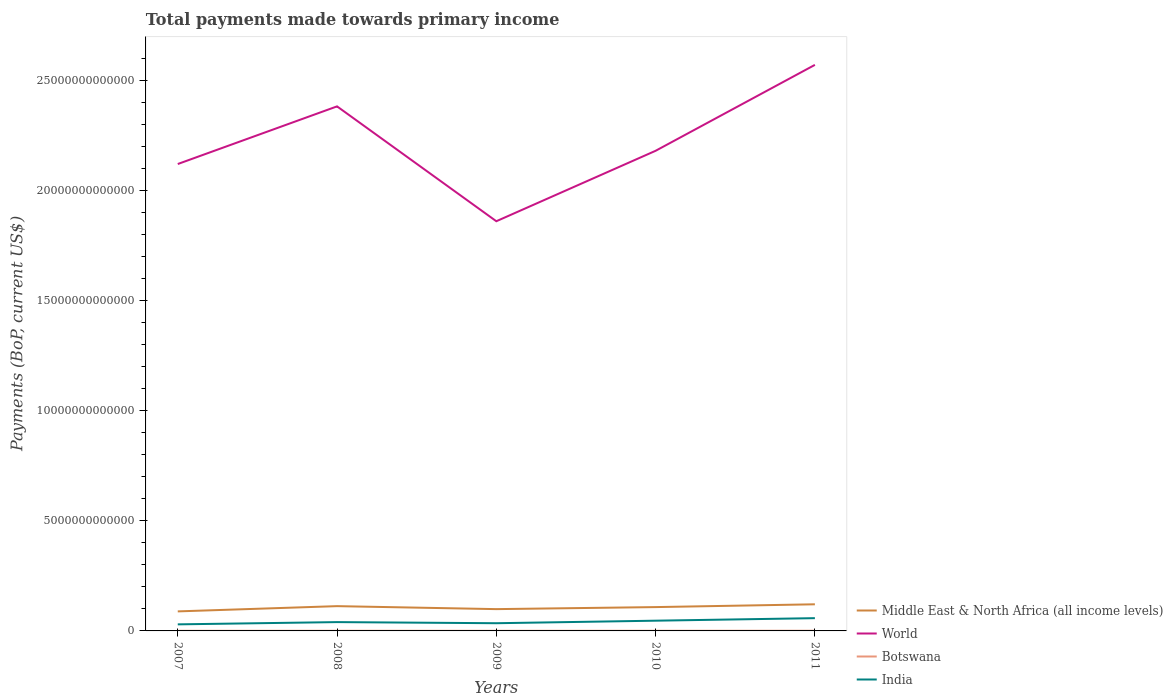How many different coloured lines are there?
Ensure brevity in your answer.  4. Does the line corresponding to World intersect with the line corresponding to Middle East & North Africa (all income levels)?
Ensure brevity in your answer.  No. Across all years, what is the maximum total payments made towards primary income in Botswana?
Keep it short and to the point. 5.86e+09. In which year was the total payments made towards primary income in Botswana maximum?
Provide a short and direct response. 2009. What is the total total payments made towards primary income in World in the graph?
Ensure brevity in your answer.  -2.62e+12. What is the difference between the highest and the second highest total payments made towards primary income in World?
Ensure brevity in your answer.  7.10e+12. How many years are there in the graph?
Offer a very short reply. 5. What is the difference between two consecutive major ticks on the Y-axis?
Offer a very short reply. 5.00e+12. Are the values on the major ticks of Y-axis written in scientific E-notation?
Ensure brevity in your answer.  No. Does the graph contain any zero values?
Your response must be concise. No. What is the title of the graph?
Provide a succinct answer. Total payments made towards primary income. What is the label or title of the Y-axis?
Ensure brevity in your answer.  Payments (BoP, current US$). What is the Payments (BoP, current US$) of Middle East & North Africa (all income levels) in 2007?
Your answer should be very brief. 8.86e+11. What is the Payments (BoP, current US$) in World in 2007?
Your answer should be very brief. 2.12e+13. What is the Payments (BoP, current US$) of Botswana in 2007?
Offer a very short reply. 6.00e+09. What is the Payments (BoP, current US$) in India in 2007?
Give a very brief answer. 2.98e+11. What is the Payments (BoP, current US$) in Middle East & North Africa (all income levels) in 2008?
Ensure brevity in your answer.  1.12e+12. What is the Payments (BoP, current US$) in World in 2008?
Make the answer very short. 2.38e+13. What is the Payments (BoP, current US$) in Botswana in 2008?
Your response must be concise. 6.81e+09. What is the Payments (BoP, current US$) of India in 2008?
Your response must be concise. 4.00e+11. What is the Payments (BoP, current US$) in Middle East & North Africa (all income levels) in 2009?
Offer a terse response. 9.90e+11. What is the Payments (BoP, current US$) of World in 2009?
Give a very brief answer. 1.86e+13. What is the Payments (BoP, current US$) in Botswana in 2009?
Make the answer very short. 5.86e+09. What is the Payments (BoP, current US$) in India in 2009?
Make the answer very short. 3.50e+11. What is the Payments (BoP, current US$) in Middle East & North Africa (all income levels) in 2010?
Offer a very short reply. 1.08e+12. What is the Payments (BoP, current US$) of World in 2010?
Keep it short and to the point. 2.18e+13. What is the Payments (BoP, current US$) in Botswana in 2010?
Ensure brevity in your answer.  7.16e+09. What is the Payments (BoP, current US$) in India in 2010?
Your response must be concise. 4.65e+11. What is the Payments (BoP, current US$) in Middle East & North Africa (all income levels) in 2011?
Make the answer very short. 1.21e+12. What is the Payments (BoP, current US$) of World in 2011?
Your response must be concise. 2.57e+13. What is the Payments (BoP, current US$) in Botswana in 2011?
Your answer should be compact. 8.39e+09. What is the Payments (BoP, current US$) in India in 2011?
Your answer should be very brief. 5.79e+11. Across all years, what is the maximum Payments (BoP, current US$) in Middle East & North Africa (all income levels)?
Keep it short and to the point. 1.21e+12. Across all years, what is the maximum Payments (BoP, current US$) in World?
Provide a short and direct response. 2.57e+13. Across all years, what is the maximum Payments (BoP, current US$) in Botswana?
Provide a short and direct response. 8.39e+09. Across all years, what is the maximum Payments (BoP, current US$) in India?
Ensure brevity in your answer.  5.79e+11. Across all years, what is the minimum Payments (BoP, current US$) in Middle East & North Africa (all income levels)?
Make the answer very short. 8.86e+11. Across all years, what is the minimum Payments (BoP, current US$) of World?
Your answer should be very brief. 1.86e+13. Across all years, what is the minimum Payments (BoP, current US$) in Botswana?
Offer a terse response. 5.86e+09. Across all years, what is the minimum Payments (BoP, current US$) in India?
Make the answer very short. 2.98e+11. What is the total Payments (BoP, current US$) in Middle East & North Africa (all income levels) in the graph?
Offer a very short reply. 5.29e+12. What is the total Payments (BoP, current US$) of World in the graph?
Make the answer very short. 1.11e+14. What is the total Payments (BoP, current US$) in Botswana in the graph?
Your response must be concise. 3.42e+1. What is the total Payments (BoP, current US$) in India in the graph?
Provide a succinct answer. 2.09e+12. What is the difference between the Payments (BoP, current US$) in Middle East & North Africa (all income levels) in 2007 and that in 2008?
Your answer should be compact. -2.38e+11. What is the difference between the Payments (BoP, current US$) in World in 2007 and that in 2008?
Give a very brief answer. -2.62e+12. What is the difference between the Payments (BoP, current US$) in Botswana in 2007 and that in 2008?
Your answer should be compact. -8.14e+08. What is the difference between the Payments (BoP, current US$) of India in 2007 and that in 2008?
Your response must be concise. -1.02e+11. What is the difference between the Payments (BoP, current US$) of Middle East & North Africa (all income levels) in 2007 and that in 2009?
Your answer should be very brief. -1.03e+11. What is the difference between the Payments (BoP, current US$) in World in 2007 and that in 2009?
Your response must be concise. 2.60e+12. What is the difference between the Payments (BoP, current US$) in Botswana in 2007 and that in 2009?
Provide a short and direct response. 1.35e+08. What is the difference between the Payments (BoP, current US$) in India in 2007 and that in 2009?
Provide a succinct answer. -5.16e+1. What is the difference between the Payments (BoP, current US$) in Middle East & North Africa (all income levels) in 2007 and that in 2010?
Offer a very short reply. -1.96e+11. What is the difference between the Payments (BoP, current US$) of World in 2007 and that in 2010?
Provide a short and direct response. -6.01e+11. What is the difference between the Payments (BoP, current US$) in Botswana in 2007 and that in 2010?
Make the answer very short. -1.17e+09. What is the difference between the Payments (BoP, current US$) in India in 2007 and that in 2010?
Your answer should be compact. -1.67e+11. What is the difference between the Payments (BoP, current US$) of Middle East & North Africa (all income levels) in 2007 and that in 2011?
Ensure brevity in your answer.  -3.22e+11. What is the difference between the Payments (BoP, current US$) in World in 2007 and that in 2011?
Keep it short and to the point. -4.50e+12. What is the difference between the Payments (BoP, current US$) of Botswana in 2007 and that in 2011?
Your answer should be compact. -2.40e+09. What is the difference between the Payments (BoP, current US$) of India in 2007 and that in 2011?
Provide a short and direct response. -2.81e+11. What is the difference between the Payments (BoP, current US$) of Middle East & North Africa (all income levels) in 2008 and that in 2009?
Keep it short and to the point. 1.35e+11. What is the difference between the Payments (BoP, current US$) of World in 2008 and that in 2009?
Offer a terse response. 5.21e+12. What is the difference between the Payments (BoP, current US$) of Botswana in 2008 and that in 2009?
Offer a terse response. 9.49e+08. What is the difference between the Payments (BoP, current US$) in India in 2008 and that in 2009?
Offer a very short reply. 5.09e+1. What is the difference between the Payments (BoP, current US$) of Middle East & North Africa (all income levels) in 2008 and that in 2010?
Provide a short and direct response. 4.28e+1. What is the difference between the Payments (BoP, current US$) in World in 2008 and that in 2010?
Your answer should be very brief. 2.02e+12. What is the difference between the Payments (BoP, current US$) in Botswana in 2008 and that in 2010?
Give a very brief answer. -3.52e+08. What is the difference between the Payments (BoP, current US$) in India in 2008 and that in 2010?
Offer a very short reply. -6.42e+1. What is the difference between the Payments (BoP, current US$) of Middle East & North Africa (all income levels) in 2008 and that in 2011?
Your answer should be compact. -8.36e+1. What is the difference between the Payments (BoP, current US$) of World in 2008 and that in 2011?
Keep it short and to the point. -1.88e+12. What is the difference between the Payments (BoP, current US$) in Botswana in 2008 and that in 2011?
Offer a very short reply. -1.58e+09. What is the difference between the Payments (BoP, current US$) of India in 2008 and that in 2011?
Offer a very short reply. -1.79e+11. What is the difference between the Payments (BoP, current US$) of Middle East & North Africa (all income levels) in 2009 and that in 2010?
Your answer should be compact. -9.24e+1. What is the difference between the Payments (BoP, current US$) of World in 2009 and that in 2010?
Keep it short and to the point. -3.20e+12. What is the difference between the Payments (BoP, current US$) in Botswana in 2009 and that in 2010?
Keep it short and to the point. -1.30e+09. What is the difference between the Payments (BoP, current US$) of India in 2009 and that in 2010?
Provide a succinct answer. -1.15e+11. What is the difference between the Payments (BoP, current US$) in Middle East & North Africa (all income levels) in 2009 and that in 2011?
Ensure brevity in your answer.  -2.19e+11. What is the difference between the Payments (BoP, current US$) in World in 2009 and that in 2011?
Offer a very short reply. -7.10e+12. What is the difference between the Payments (BoP, current US$) in Botswana in 2009 and that in 2011?
Offer a terse response. -2.53e+09. What is the difference between the Payments (BoP, current US$) in India in 2009 and that in 2011?
Offer a terse response. -2.30e+11. What is the difference between the Payments (BoP, current US$) of Middle East & North Africa (all income levels) in 2010 and that in 2011?
Offer a very short reply. -1.26e+11. What is the difference between the Payments (BoP, current US$) of World in 2010 and that in 2011?
Ensure brevity in your answer.  -3.90e+12. What is the difference between the Payments (BoP, current US$) of Botswana in 2010 and that in 2011?
Your response must be concise. -1.23e+09. What is the difference between the Payments (BoP, current US$) of India in 2010 and that in 2011?
Offer a terse response. -1.15e+11. What is the difference between the Payments (BoP, current US$) in Middle East & North Africa (all income levels) in 2007 and the Payments (BoP, current US$) in World in 2008?
Make the answer very short. -2.29e+13. What is the difference between the Payments (BoP, current US$) in Middle East & North Africa (all income levels) in 2007 and the Payments (BoP, current US$) in Botswana in 2008?
Offer a terse response. 8.80e+11. What is the difference between the Payments (BoP, current US$) in Middle East & North Africa (all income levels) in 2007 and the Payments (BoP, current US$) in India in 2008?
Give a very brief answer. 4.86e+11. What is the difference between the Payments (BoP, current US$) of World in 2007 and the Payments (BoP, current US$) of Botswana in 2008?
Provide a short and direct response. 2.12e+13. What is the difference between the Payments (BoP, current US$) in World in 2007 and the Payments (BoP, current US$) in India in 2008?
Provide a short and direct response. 2.08e+13. What is the difference between the Payments (BoP, current US$) in Botswana in 2007 and the Payments (BoP, current US$) in India in 2008?
Offer a terse response. -3.94e+11. What is the difference between the Payments (BoP, current US$) of Middle East & North Africa (all income levels) in 2007 and the Payments (BoP, current US$) of World in 2009?
Provide a short and direct response. -1.77e+13. What is the difference between the Payments (BoP, current US$) in Middle East & North Africa (all income levels) in 2007 and the Payments (BoP, current US$) in Botswana in 2009?
Provide a succinct answer. 8.81e+11. What is the difference between the Payments (BoP, current US$) in Middle East & North Africa (all income levels) in 2007 and the Payments (BoP, current US$) in India in 2009?
Give a very brief answer. 5.37e+11. What is the difference between the Payments (BoP, current US$) of World in 2007 and the Payments (BoP, current US$) of Botswana in 2009?
Your answer should be compact. 2.12e+13. What is the difference between the Payments (BoP, current US$) in World in 2007 and the Payments (BoP, current US$) in India in 2009?
Your answer should be very brief. 2.08e+13. What is the difference between the Payments (BoP, current US$) of Botswana in 2007 and the Payments (BoP, current US$) of India in 2009?
Provide a short and direct response. -3.44e+11. What is the difference between the Payments (BoP, current US$) of Middle East & North Africa (all income levels) in 2007 and the Payments (BoP, current US$) of World in 2010?
Make the answer very short. -2.09e+13. What is the difference between the Payments (BoP, current US$) in Middle East & North Africa (all income levels) in 2007 and the Payments (BoP, current US$) in Botswana in 2010?
Provide a short and direct response. 8.79e+11. What is the difference between the Payments (BoP, current US$) in Middle East & North Africa (all income levels) in 2007 and the Payments (BoP, current US$) in India in 2010?
Your answer should be very brief. 4.22e+11. What is the difference between the Payments (BoP, current US$) of World in 2007 and the Payments (BoP, current US$) of Botswana in 2010?
Your response must be concise. 2.12e+13. What is the difference between the Payments (BoP, current US$) in World in 2007 and the Payments (BoP, current US$) in India in 2010?
Keep it short and to the point. 2.07e+13. What is the difference between the Payments (BoP, current US$) in Botswana in 2007 and the Payments (BoP, current US$) in India in 2010?
Ensure brevity in your answer.  -4.59e+11. What is the difference between the Payments (BoP, current US$) of Middle East & North Africa (all income levels) in 2007 and the Payments (BoP, current US$) of World in 2011?
Give a very brief answer. -2.48e+13. What is the difference between the Payments (BoP, current US$) in Middle East & North Africa (all income levels) in 2007 and the Payments (BoP, current US$) in Botswana in 2011?
Provide a succinct answer. 8.78e+11. What is the difference between the Payments (BoP, current US$) of Middle East & North Africa (all income levels) in 2007 and the Payments (BoP, current US$) of India in 2011?
Offer a very short reply. 3.07e+11. What is the difference between the Payments (BoP, current US$) of World in 2007 and the Payments (BoP, current US$) of Botswana in 2011?
Provide a short and direct response. 2.12e+13. What is the difference between the Payments (BoP, current US$) in World in 2007 and the Payments (BoP, current US$) in India in 2011?
Your answer should be compact. 2.06e+13. What is the difference between the Payments (BoP, current US$) of Botswana in 2007 and the Payments (BoP, current US$) of India in 2011?
Your answer should be compact. -5.73e+11. What is the difference between the Payments (BoP, current US$) in Middle East & North Africa (all income levels) in 2008 and the Payments (BoP, current US$) in World in 2009?
Provide a short and direct response. -1.75e+13. What is the difference between the Payments (BoP, current US$) in Middle East & North Africa (all income levels) in 2008 and the Payments (BoP, current US$) in Botswana in 2009?
Make the answer very short. 1.12e+12. What is the difference between the Payments (BoP, current US$) in Middle East & North Africa (all income levels) in 2008 and the Payments (BoP, current US$) in India in 2009?
Provide a short and direct response. 7.75e+11. What is the difference between the Payments (BoP, current US$) of World in 2008 and the Payments (BoP, current US$) of Botswana in 2009?
Keep it short and to the point. 2.38e+13. What is the difference between the Payments (BoP, current US$) in World in 2008 and the Payments (BoP, current US$) in India in 2009?
Provide a succinct answer. 2.35e+13. What is the difference between the Payments (BoP, current US$) in Botswana in 2008 and the Payments (BoP, current US$) in India in 2009?
Provide a succinct answer. -3.43e+11. What is the difference between the Payments (BoP, current US$) in Middle East & North Africa (all income levels) in 2008 and the Payments (BoP, current US$) in World in 2010?
Your answer should be compact. -2.07e+13. What is the difference between the Payments (BoP, current US$) of Middle East & North Africa (all income levels) in 2008 and the Payments (BoP, current US$) of Botswana in 2010?
Your response must be concise. 1.12e+12. What is the difference between the Payments (BoP, current US$) in Middle East & North Africa (all income levels) in 2008 and the Payments (BoP, current US$) in India in 2010?
Provide a succinct answer. 6.60e+11. What is the difference between the Payments (BoP, current US$) in World in 2008 and the Payments (BoP, current US$) in Botswana in 2010?
Offer a very short reply. 2.38e+13. What is the difference between the Payments (BoP, current US$) in World in 2008 and the Payments (BoP, current US$) in India in 2010?
Ensure brevity in your answer.  2.34e+13. What is the difference between the Payments (BoP, current US$) of Botswana in 2008 and the Payments (BoP, current US$) of India in 2010?
Ensure brevity in your answer.  -4.58e+11. What is the difference between the Payments (BoP, current US$) in Middle East & North Africa (all income levels) in 2008 and the Payments (BoP, current US$) in World in 2011?
Keep it short and to the point. -2.46e+13. What is the difference between the Payments (BoP, current US$) of Middle East & North Africa (all income levels) in 2008 and the Payments (BoP, current US$) of Botswana in 2011?
Your response must be concise. 1.12e+12. What is the difference between the Payments (BoP, current US$) in Middle East & North Africa (all income levels) in 2008 and the Payments (BoP, current US$) in India in 2011?
Your answer should be compact. 5.46e+11. What is the difference between the Payments (BoP, current US$) of World in 2008 and the Payments (BoP, current US$) of Botswana in 2011?
Give a very brief answer. 2.38e+13. What is the difference between the Payments (BoP, current US$) in World in 2008 and the Payments (BoP, current US$) in India in 2011?
Your answer should be very brief. 2.32e+13. What is the difference between the Payments (BoP, current US$) of Botswana in 2008 and the Payments (BoP, current US$) of India in 2011?
Your answer should be compact. -5.72e+11. What is the difference between the Payments (BoP, current US$) in Middle East & North Africa (all income levels) in 2009 and the Payments (BoP, current US$) in World in 2010?
Ensure brevity in your answer.  -2.08e+13. What is the difference between the Payments (BoP, current US$) in Middle East & North Africa (all income levels) in 2009 and the Payments (BoP, current US$) in Botswana in 2010?
Your response must be concise. 9.83e+11. What is the difference between the Payments (BoP, current US$) in Middle East & North Africa (all income levels) in 2009 and the Payments (BoP, current US$) in India in 2010?
Make the answer very short. 5.25e+11. What is the difference between the Payments (BoP, current US$) in World in 2009 and the Payments (BoP, current US$) in Botswana in 2010?
Make the answer very short. 1.86e+13. What is the difference between the Payments (BoP, current US$) in World in 2009 and the Payments (BoP, current US$) in India in 2010?
Keep it short and to the point. 1.81e+13. What is the difference between the Payments (BoP, current US$) of Botswana in 2009 and the Payments (BoP, current US$) of India in 2010?
Make the answer very short. -4.59e+11. What is the difference between the Payments (BoP, current US$) of Middle East & North Africa (all income levels) in 2009 and the Payments (BoP, current US$) of World in 2011?
Ensure brevity in your answer.  -2.47e+13. What is the difference between the Payments (BoP, current US$) of Middle East & North Africa (all income levels) in 2009 and the Payments (BoP, current US$) of Botswana in 2011?
Your response must be concise. 9.81e+11. What is the difference between the Payments (BoP, current US$) of Middle East & North Africa (all income levels) in 2009 and the Payments (BoP, current US$) of India in 2011?
Ensure brevity in your answer.  4.10e+11. What is the difference between the Payments (BoP, current US$) of World in 2009 and the Payments (BoP, current US$) of Botswana in 2011?
Offer a very short reply. 1.86e+13. What is the difference between the Payments (BoP, current US$) of World in 2009 and the Payments (BoP, current US$) of India in 2011?
Make the answer very short. 1.80e+13. What is the difference between the Payments (BoP, current US$) in Botswana in 2009 and the Payments (BoP, current US$) in India in 2011?
Provide a succinct answer. -5.73e+11. What is the difference between the Payments (BoP, current US$) of Middle East & North Africa (all income levels) in 2010 and the Payments (BoP, current US$) of World in 2011?
Offer a very short reply. -2.46e+13. What is the difference between the Payments (BoP, current US$) of Middle East & North Africa (all income levels) in 2010 and the Payments (BoP, current US$) of Botswana in 2011?
Your answer should be very brief. 1.07e+12. What is the difference between the Payments (BoP, current US$) in Middle East & North Africa (all income levels) in 2010 and the Payments (BoP, current US$) in India in 2011?
Keep it short and to the point. 5.03e+11. What is the difference between the Payments (BoP, current US$) in World in 2010 and the Payments (BoP, current US$) in Botswana in 2011?
Ensure brevity in your answer.  2.18e+13. What is the difference between the Payments (BoP, current US$) of World in 2010 and the Payments (BoP, current US$) of India in 2011?
Provide a short and direct response. 2.12e+13. What is the difference between the Payments (BoP, current US$) of Botswana in 2010 and the Payments (BoP, current US$) of India in 2011?
Your answer should be very brief. -5.72e+11. What is the average Payments (BoP, current US$) of Middle East & North Africa (all income levels) per year?
Provide a succinct answer. 1.06e+12. What is the average Payments (BoP, current US$) in World per year?
Your answer should be compact. 2.22e+13. What is the average Payments (BoP, current US$) of Botswana per year?
Your response must be concise. 6.84e+09. What is the average Payments (BoP, current US$) of India per year?
Ensure brevity in your answer.  4.18e+11. In the year 2007, what is the difference between the Payments (BoP, current US$) of Middle East & North Africa (all income levels) and Payments (BoP, current US$) of World?
Your answer should be compact. -2.03e+13. In the year 2007, what is the difference between the Payments (BoP, current US$) of Middle East & North Africa (all income levels) and Payments (BoP, current US$) of Botswana?
Your response must be concise. 8.80e+11. In the year 2007, what is the difference between the Payments (BoP, current US$) of Middle East & North Africa (all income levels) and Payments (BoP, current US$) of India?
Provide a succinct answer. 5.89e+11. In the year 2007, what is the difference between the Payments (BoP, current US$) in World and Payments (BoP, current US$) in Botswana?
Keep it short and to the point. 2.12e+13. In the year 2007, what is the difference between the Payments (BoP, current US$) of World and Payments (BoP, current US$) of India?
Keep it short and to the point. 2.09e+13. In the year 2007, what is the difference between the Payments (BoP, current US$) in Botswana and Payments (BoP, current US$) in India?
Ensure brevity in your answer.  -2.92e+11. In the year 2008, what is the difference between the Payments (BoP, current US$) of Middle East & North Africa (all income levels) and Payments (BoP, current US$) of World?
Keep it short and to the point. -2.27e+13. In the year 2008, what is the difference between the Payments (BoP, current US$) of Middle East & North Africa (all income levels) and Payments (BoP, current US$) of Botswana?
Your answer should be very brief. 1.12e+12. In the year 2008, what is the difference between the Payments (BoP, current US$) of Middle East & North Africa (all income levels) and Payments (BoP, current US$) of India?
Give a very brief answer. 7.24e+11. In the year 2008, what is the difference between the Payments (BoP, current US$) in World and Payments (BoP, current US$) in Botswana?
Your answer should be very brief. 2.38e+13. In the year 2008, what is the difference between the Payments (BoP, current US$) of World and Payments (BoP, current US$) of India?
Give a very brief answer. 2.34e+13. In the year 2008, what is the difference between the Payments (BoP, current US$) of Botswana and Payments (BoP, current US$) of India?
Make the answer very short. -3.94e+11. In the year 2009, what is the difference between the Payments (BoP, current US$) in Middle East & North Africa (all income levels) and Payments (BoP, current US$) in World?
Offer a terse response. -1.76e+13. In the year 2009, what is the difference between the Payments (BoP, current US$) of Middle East & North Africa (all income levels) and Payments (BoP, current US$) of Botswana?
Offer a terse response. 9.84e+11. In the year 2009, what is the difference between the Payments (BoP, current US$) of Middle East & North Africa (all income levels) and Payments (BoP, current US$) of India?
Make the answer very short. 6.40e+11. In the year 2009, what is the difference between the Payments (BoP, current US$) of World and Payments (BoP, current US$) of Botswana?
Make the answer very short. 1.86e+13. In the year 2009, what is the difference between the Payments (BoP, current US$) in World and Payments (BoP, current US$) in India?
Your answer should be very brief. 1.83e+13. In the year 2009, what is the difference between the Payments (BoP, current US$) in Botswana and Payments (BoP, current US$) in India?
Ensure brevity in your answer.  -3.44e+11. In the year 2010, what is the difference between the Payments (BoP, current US$) in Middle East & North Africa (all income levels) and Payments (BoP, current US$) in World?
Offer a terse response. -2.07e+13. In the year 2010, what is the difference between the Payments (BoP, current US$) in Middle East & North Africa (all income levels) and Payments (BoP, current US$) in Botswana?
Offer a terse response. 1.07e+12. In the year 2010, what is the difference between the Payments (BoP, current US$) of Middle East & North Africa (all income levels) and Payments (BoP, current US$) of India?
Provide a succinct answer. 6.17e+11. In the year 2010, what is the difference between the Payments (BoP, current US$) in World and Payments (BoP, current US$) in Botswana?
Offer a very short reply. 2.18e+13. In the year 2010, what is the difference between the Payments (BoP, current US$) of World and Payments (BoP, current US$) of India?
Provide a short and direct response. 2.13e+13. In the year 2010, what is the difference between the Payments (BoP, current US$) in Botswana and Payments (BoP, current US$) in India?
Offer a terse response. -4.57e+11. In the year 2011, what is the difference between the Payments (BoP, current US$) of Middle East & North Africa (all income levels) and Payments (BoP, current US$) of World?
Provide a succinct answer. -2.45e+13. In the year 2011, what is the difference between the Payments (BoP, current US$) of Middle East & North Africa (all income levels) and Payments (BoP, current US$) of Botswana?
Offer a terse response. 1.20e+12. In the year 2011, what is the difference between the Payments (BoP, current US$) of Middle East & North Africa (all income levels) and Payments (BoP, current US$) of India?
Ensure brevity in your answer.  6.29e+11. In the year 2011, what is the difference between the Payments (BoP, current US$) in World and Payments (BoP, current US$) in Botswana?
Ensure brevity in your answer.  2.57e+13. In the year 2011, what is the difference between the Payments (BoP, current US$) of World and Payments (BoP, current US$) of India?
Offer a terse response. 2.51e+13. In the year 2011, what is the difference between the Payments (BoP, current US$) of Botswana and Payments (BoP, current US$) of India?
Keep it short and to the point. -5.71e+11. What is the ratio of the Payments (BoP, current US$) in Middle East & North Africa (all income levels) in 2007 to that in 2008?
Offer a very short reply. 0.79. What is the ratio of the Payments (BoP, current US$) of World in 2007 to that in 2008?
Give a very brief answer. 0.89. What is the ratio of the Payments (BoP, current US$) of Botswana in 2007 to that in 2008?
Offer a terse response. 0.88. What is the ratio of the Payments (BoP, current US$) of India in 2007 to that in 2008?
Give a very brief answer. 0.74. What is the ratio of the Payments (BoP, current US$) in Middle East & North Africa (all income levels) in 2007 to that in 2009?
Make the answer very short. 0.9. What is the ratio of the Payments (BoP, current US$) of World in 2007 to that in 2009?
Keep it short and to the point. 1.14. What is the ratio of the Payments (BoP, current US$) of India in 2007 to that in 2009?
Ensure brevity in your answer.  0.85. What is the ratio of the Payments (BoP, current US$) of Middle East & North Africa (all income levels) in 2007 to that in 2010?
Your response must be concise. 0.82. What is the ratio of the Payments (BoP, current US$) of World in 2007 to that in 2010?
Offer a terse response. 0.97. What is the ratio of the Payments (BoP, current US$) of Botswana in 2007 to that in 2010?
Provide a succinct answer. 0.84. What is the ratio of the Payments (BoP, current US$) of India in 2007 to that in 2010?
Ensure brevity in your answer.  0.64. What is the ratio of the Payments (BoP, current US$) in Middle East & North Africa (all income levels) in 2007 to that in 2011?
Ensure brevity in your answer.  0.73. What is the ratio of the Payments (BoP, current US$) in World in 2007 to that in 2011?
Offer a terse response. 0.82. What is the ratio of the Payments (BoP, current US$) of Botswana in 2007 to that in 2011?
Provide a short and direct response. 0.71. What is the ratio of the Payments (BoP, current US$) of India in 2007 to that in 2011?
Offer a terse response. 0.51. What is the ratio of the Payments (BoP, current US$) of Middle East & North Africa (all income levels) in 2008 to that in 2009?
Your answer should be compact. 1.14. What is the ratio of the Payments (BoP, current US$) of World in 2008 to that in 2009?
Offer a very short reply. 1.28. What is the ratio of the Payments (BoP, current US$) in Botswana in 2008 to that in 2009?
Ensure brevity in your answer.  1.16. What is the ratio of the Payments (BoP, current US$) of India in 2008 to that in 2009?
Keep it short and to the point. 1.15. What is the ratio of the Payments (BoP, current US$) in Middle East & North Africa (all income levels) in 2008 to that in 2010?
Provide a succinct answer. 1.04. What is the ratio of the Payments (BoP, current US$) of World in 2008 to that in 2010?
Offer a terse response. 1.09. What is the ratio of the Payments (BoP, current US$) of Botswana in 2008 to that in 2010?
Keep it short and to the point. 0.95. What is the ratio of the Payments (BoP, current US$) in India in 2008 to that in 2010?
Make the answer very short. 0.86. What is the ratio of the Payments (BoP, current US$) of Middle East & North Africa (all income levels) in 2008 to that in 2011?
Give a very brief answer. 0.93. What is the ratio of the Payments (BoP, current US$) of World in 2008 to that in 2011?
Give a very brief answer. 0.93. What is the ratio of the Payments (BoP, current US$) in Botswana in 2008 to that in 2011?
Your response must be concise. 0.81. What is the ratio of the Payments (BoP, current US$) of India in 2008 to that in 2011?
Provide a succinct answer. 0.69. What is the ratio of the Payments (BoP, current US$) of Middle East & North Africa (all income levels) in 2009 to that in 2010?
Your answer should be compact. 0.91. What is the ratio of the Payments (BoP, current US$) in World in 2009 to that in 2010?
Give a very brief answer. 0.85. What is the ratio of the Payments (BoP, current US$) in Botswana in 2009 to that in 2010?
Your answer should be compact. 0.82. What is the ratio of the Payments (BoP, current US$) in India in 2009 to that in 2010?
Provide a succinct answer. 0.75. What is the ratio of the Payments (BoP, current US$) in Middle East & North Africa (all income levels) in 2009 to that in 2011?
Offer a terse response. 0.82. What is the ratio of the Payments (BoP, current US$) in World in 2009 to that in 2011?
Provide a short and direct response. 0.72. What is the ratio of the Payments (BoP, current US$) of Botswana in 2009 to that in 2011?
Your answer should be compact. 0.7. What is the ratio of the Payments (BoP, current US$) in India in 2009 to that in 2011?
Give a very brief answer. 0.6. What is the ratio of the Payments (BoP, current US$) in Middle East & North Africa (all income levels) in 2010 to that in 2011?
Your response must be concise. 0.9. What is the ratio of the Payments (BoP, current US$) of World in 2010 to that in 2011?
Make the answer very short. 0.85. What is the ratio of the Payments (BoP, current US$) of Botswana in 2010 to that in 2011?
Provide a short and direct response. 0.85. What is the ratio of the Payments (BoP, current US$) of India in 2010 to that in 2011?
Provide a short and direct response. 0.8. What is the difference between the highest and the second highest Payments (BoP, current US$) of Middle East & North Africa (all income levels)?
Your response must be concise. 8.36e+1. What is the difference between the highest and the second highest Payments (BoP, current US$) in World?
Offer a terse response. 1.88e+12. What is the difference between the highest and the second highest Payments (BoP, current US$) of Botswana?
Provide a short and direct response. 1.23e+09. What is the difference between the highest and the second highest Payments (BoP, current US$) in India?
Provide a succinct answer. 1.15e+11. What is the difference between the highest and the lowest Payments (BoP, current US$) of Middle East & North Africa (all income levels)?
Your answer should be compact. 3.22e+11. What is the difference between the highest and the lowest Payments (BoP, current US$) of World?
Your answer should be compact. 7.10e+12. What is the difference between the highest and the lowest Payments (BoP, current US$) of Botswana?
Provide a succinct answer. 2.53e+09. What is the difference between the highest and the lowest Payments (BoP, current US$) in India?
Give a very brief answer. 2.81e+11. 